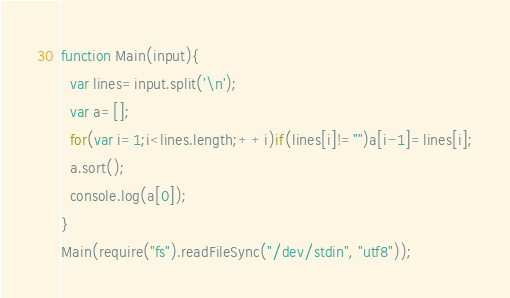<code> <loc_0><loc_0><loc_500><loc_500><_JavaScript_>function Main(input){
  var lines=input.split('\n');
  var a=[];
  for(var i=1;i<lines.length;++i)if(lines[i]!="")a[i-1]=lines[i];
  a.sort();
  console.log(a[0]);
}
Main(require("fs").readFileSync("/dev/stdin", "utf8"));</code> 